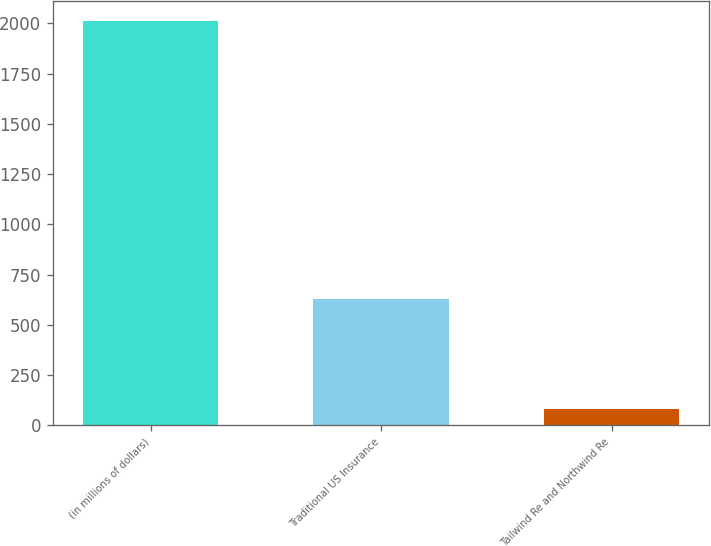Convert chart. <chart><loc_0><loc_0><loc_500><loc_500><bar_chart><fcel>(in millions of dollars)<fcel>Traditional US Insurance<fcel>Tailwind Re and Northwind Re<nl><fcel>2010<fcel>628.8<fcel>79.1<nl></chart> 